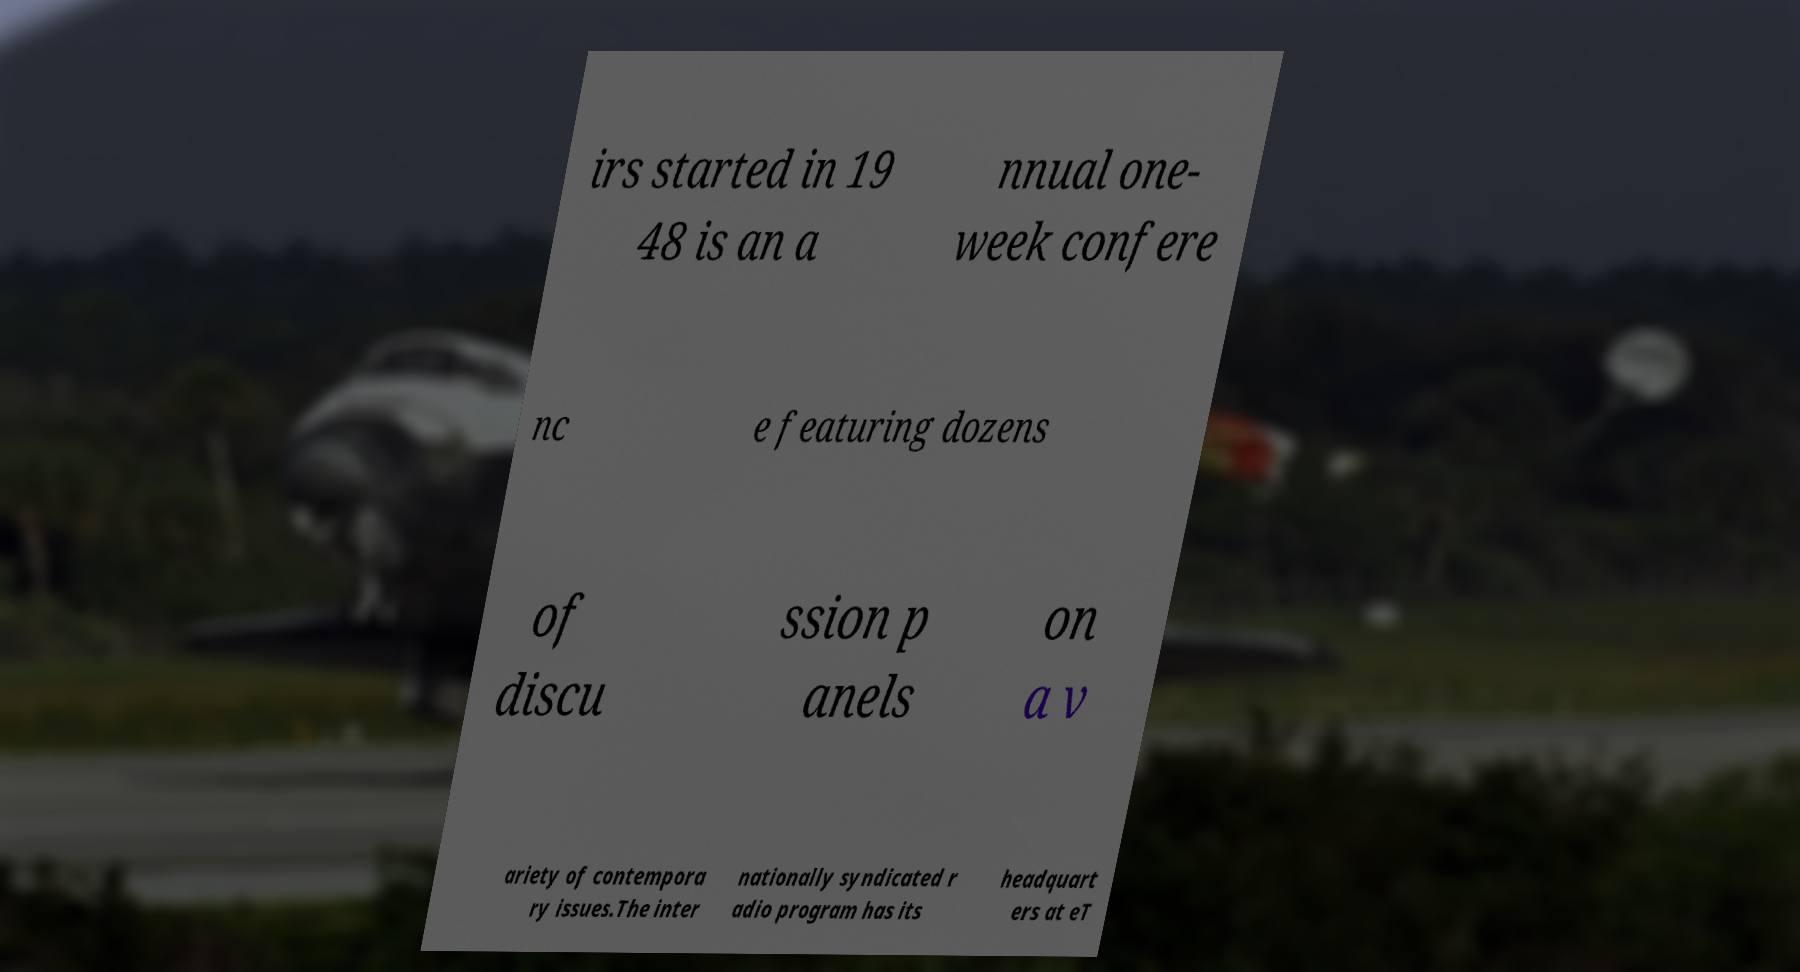For documentation purposes, I need the text within this image transcribed. Could you provide that? irs started in 19 48 is an a nnual one- week confere nc e featuring dozens of discu ssion p anels on a v ariety of contempora ry issues.The inter nationally syndicated r adio program has its headquart ers at eT 